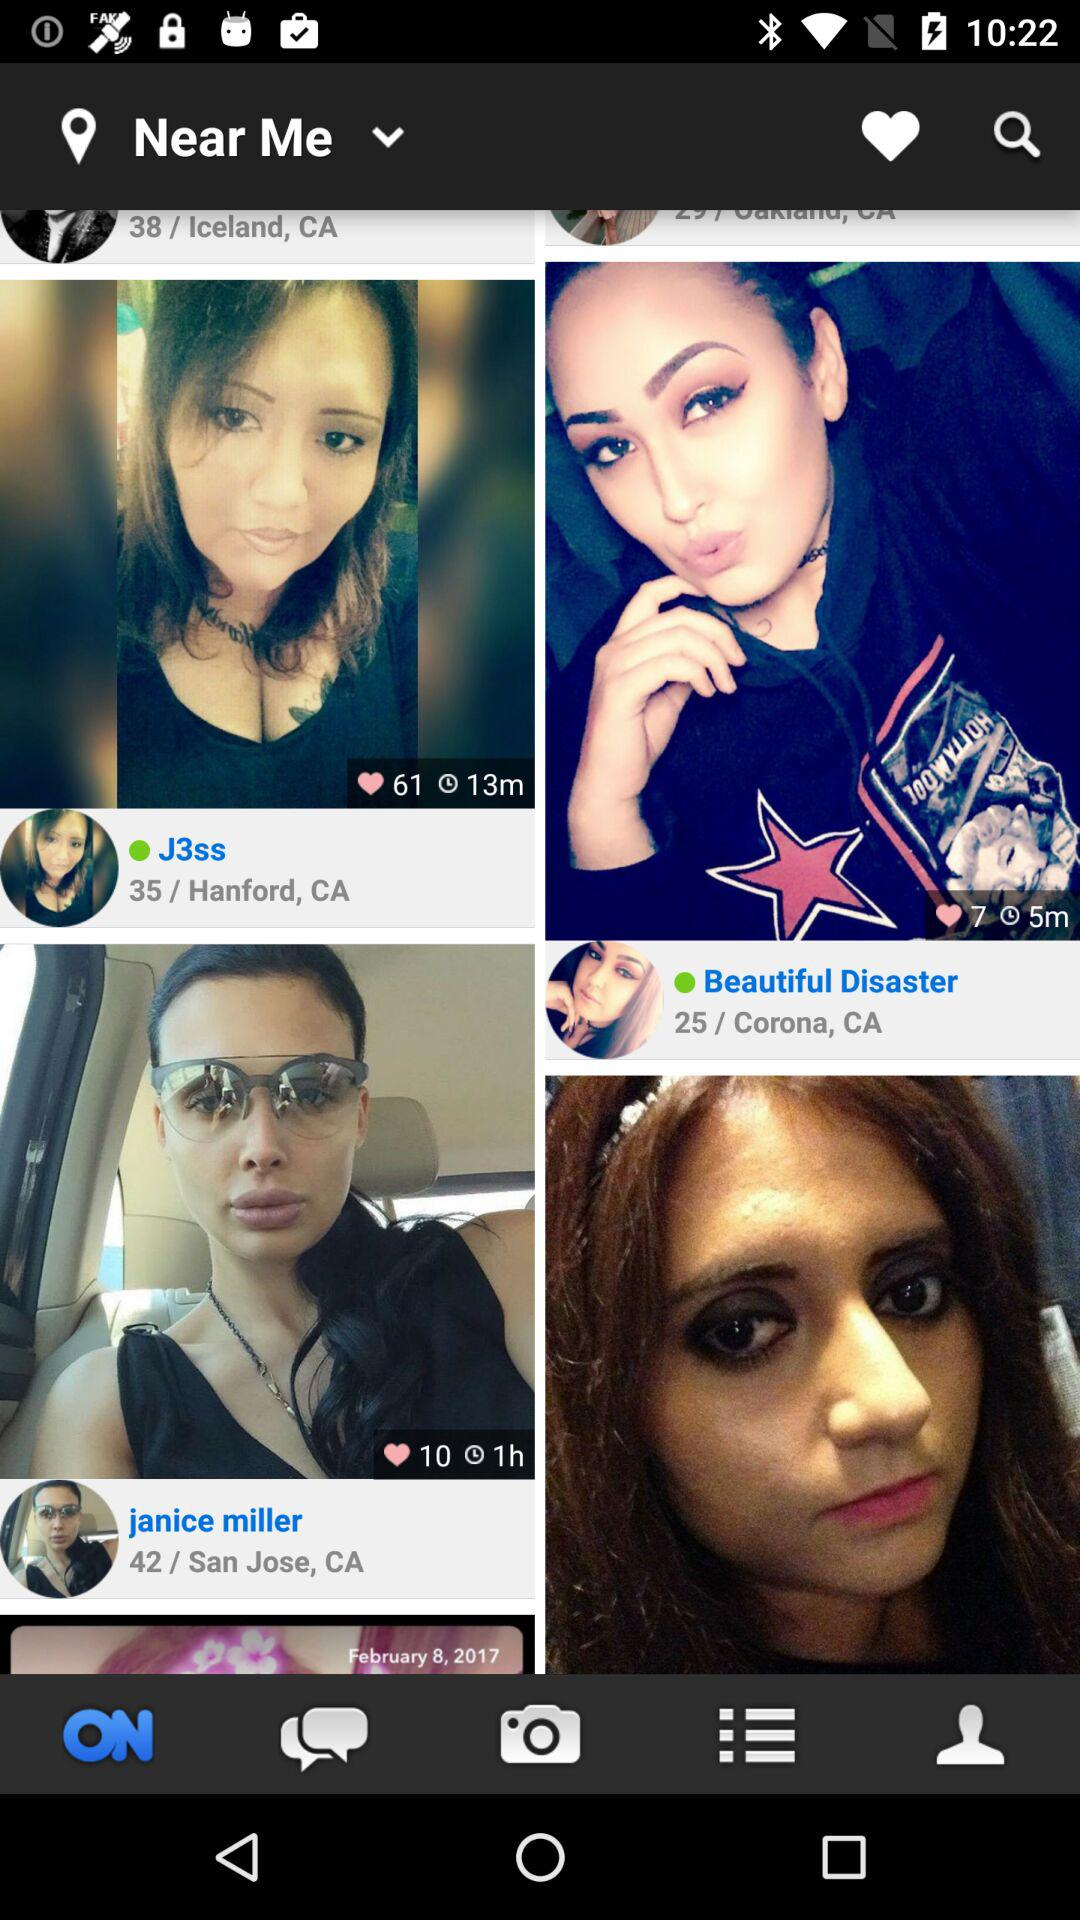What is the age of Janice Miller? Janice Miller is 42 years old. 